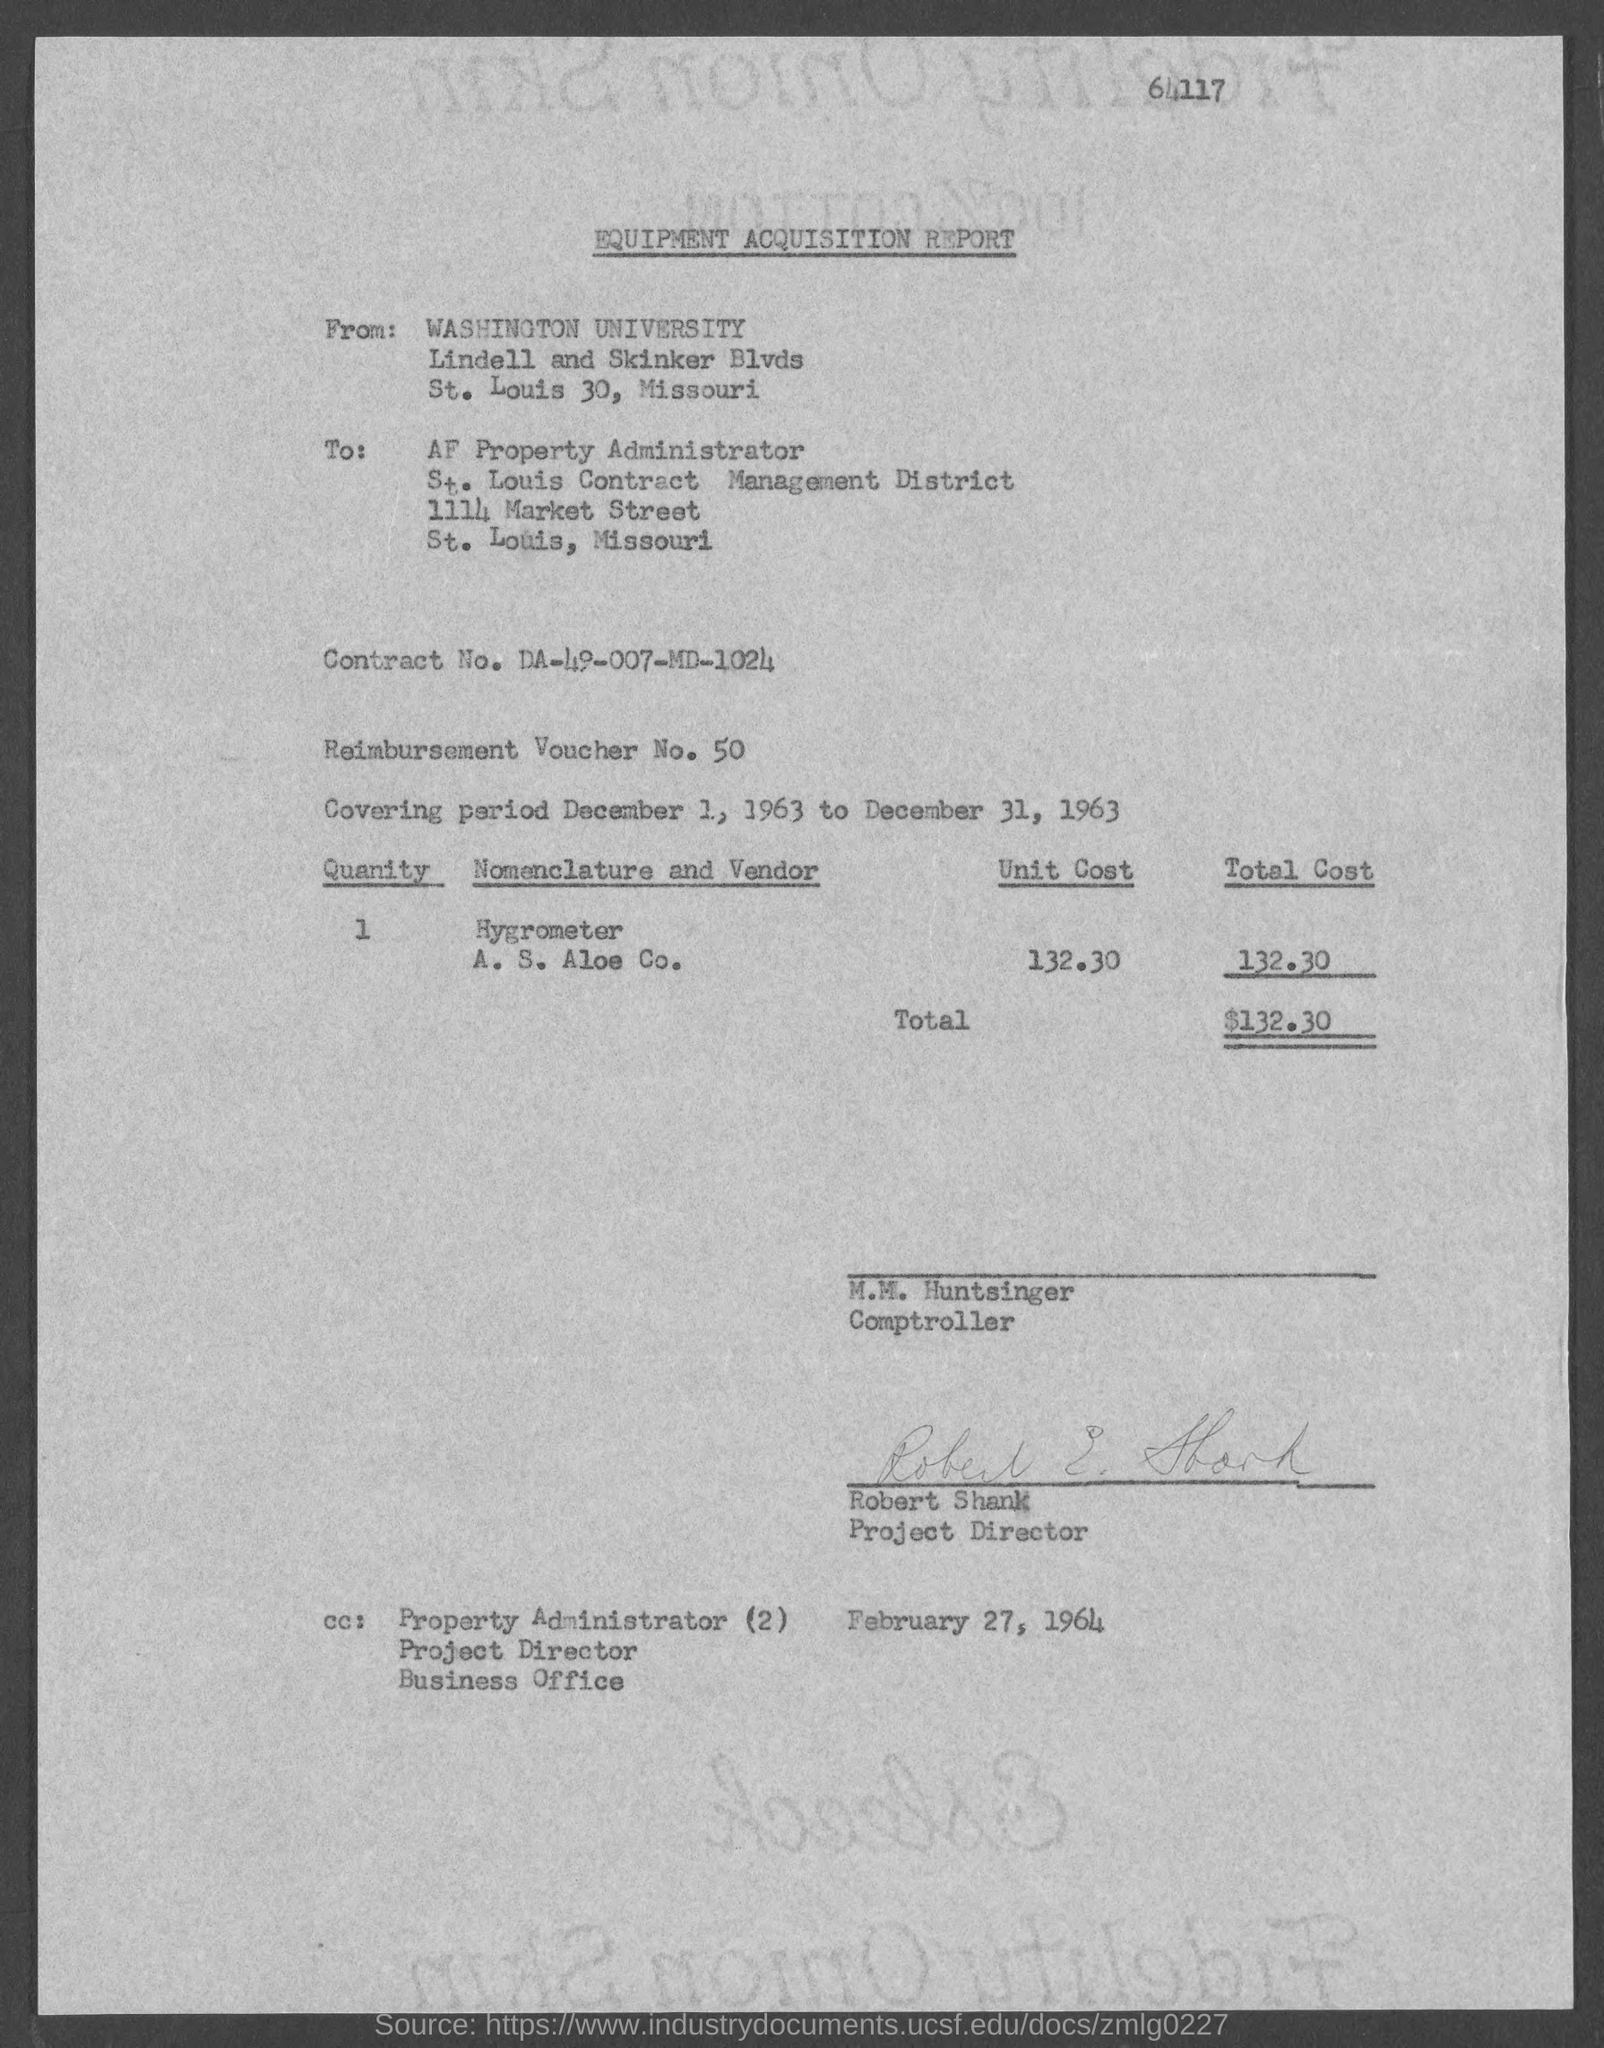What is the name of the report ?
Provide a succinct answer. EQUIPMENT ACQUISITION REPORT. What is the street address of washington university ?
Your response must be concise. Lindell and Skinker Blvds. What is the street address of af property administrator ?
Give a very brief answer. 1114 market street. What is the contract no.?
Your answer should be very brief. DA-49-007-MD-1024. What is the reimbursement voucher no. ?
Offer a terse response. 50. What is the total cost ?
Your response must be concise. $132.30. Who is the comptroller ?
Your answer should be compact. M.M. HUNTSINGER. 